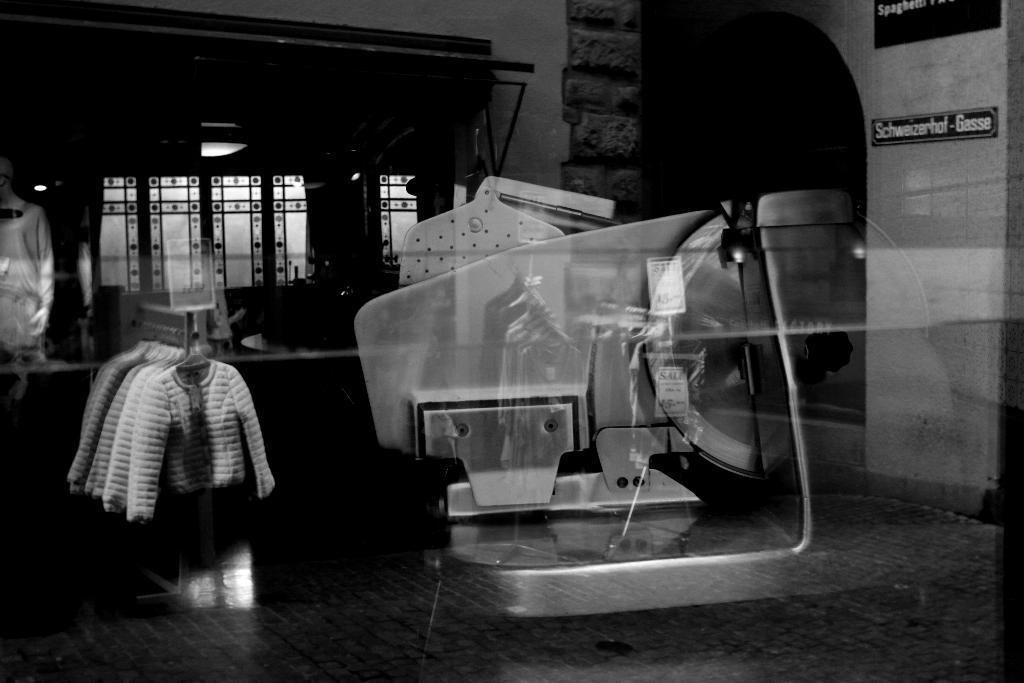How would you summarize this image in a sentence or two? This is a black and white image and edited image. There is reflection of clothes. There is a reflection of object. In the background of the image there is a window. 